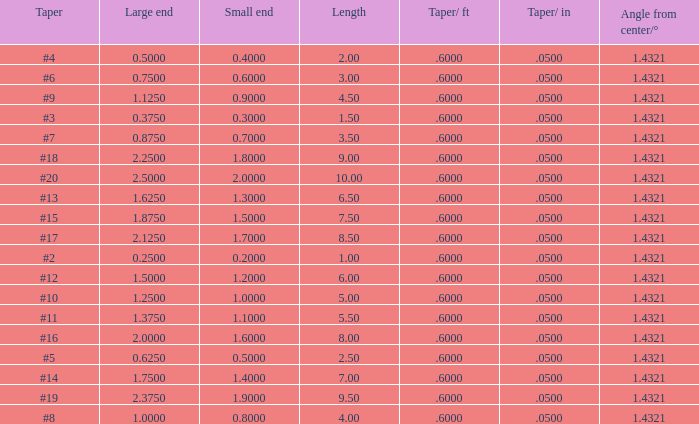Which Angle from center/° has a Taper/ft smaller than 0.6000000000000001? 19.0. 